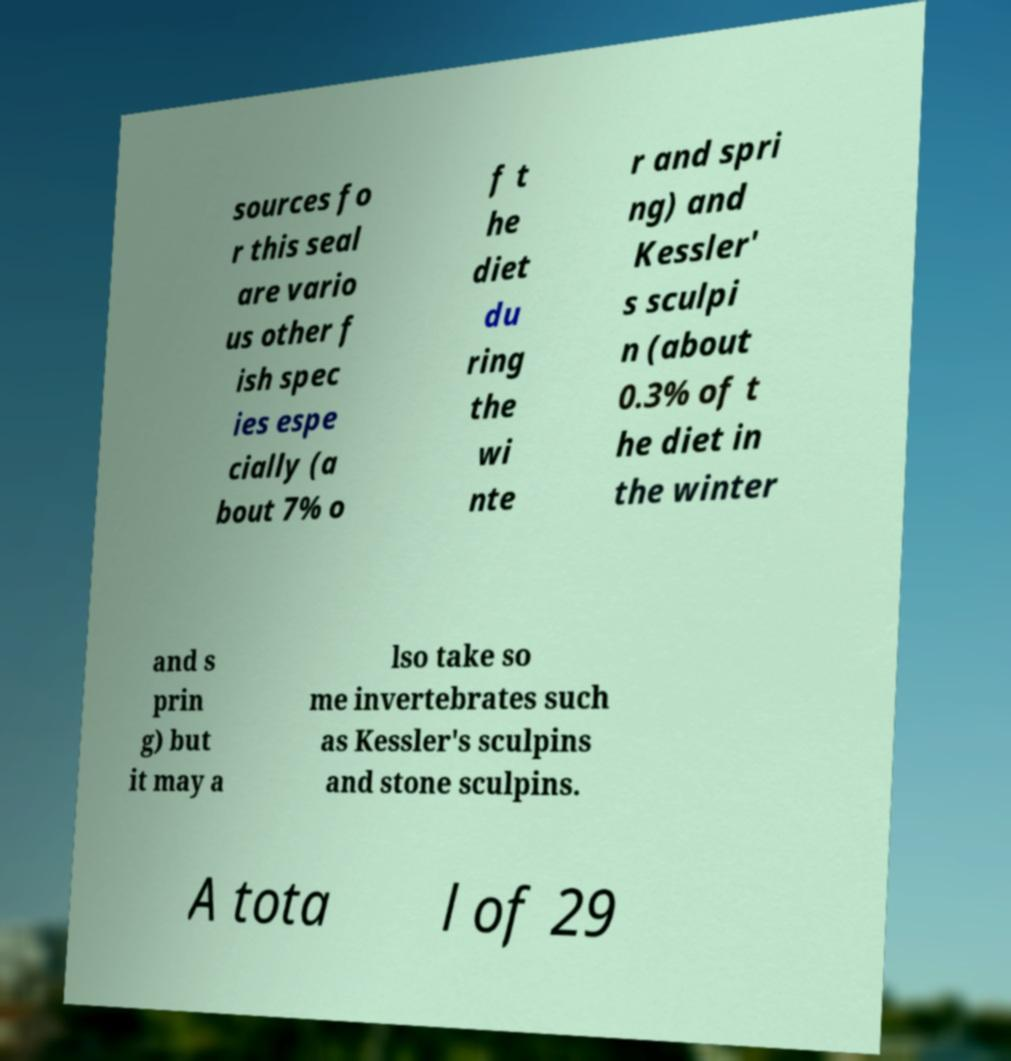I need the written content from this picture converted into text. Can you do that? sources fo r this seal are vario us other f ish spec ies espe cially (a bout 7% o f t he diet du ring the wi nte r and spri ng) and Kessler' s sculpi n (about 0.3% of t he diet in the winter and s prin g) but it may a lso take so me invertebrates such as Kessler's sculpins and stone sculpins. A tota l of 29 